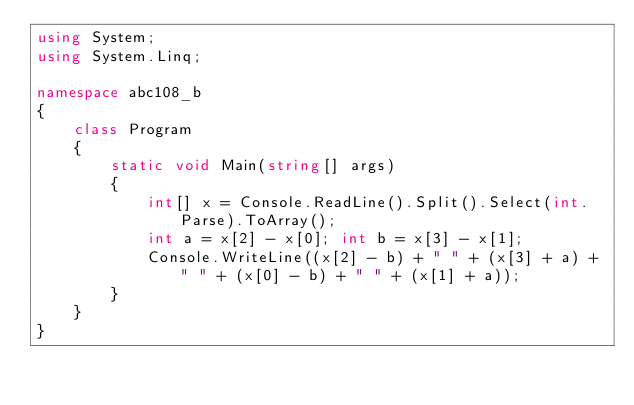<code> <loc_0><loc_0><loc_500><loc_500><_C#_>using System;
using System.Linq;

namespace abc108_b
{
	class Program
	{
		static void Main(string[] args)
		{
			int[] x = Console.ReadLine().Split().Select(int.Parse).ToArray();
			int a = x[2] - x[0]; int b = x[3] - x[1];
			Console.WriteLine((x[2] - b) + " " + (x[3] + a) + " " + (x[0] - b) + " " + (x[1] + a));
		}
	}
}</code> 